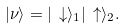Convert formula to latex. <formula><loc_0><loc_0><loc_500><loc_500>| \nu \rangle = | \, \downarrow \rangle _ { 1 } | \, \uparrow \rangle _ { 2 } .</formula> 